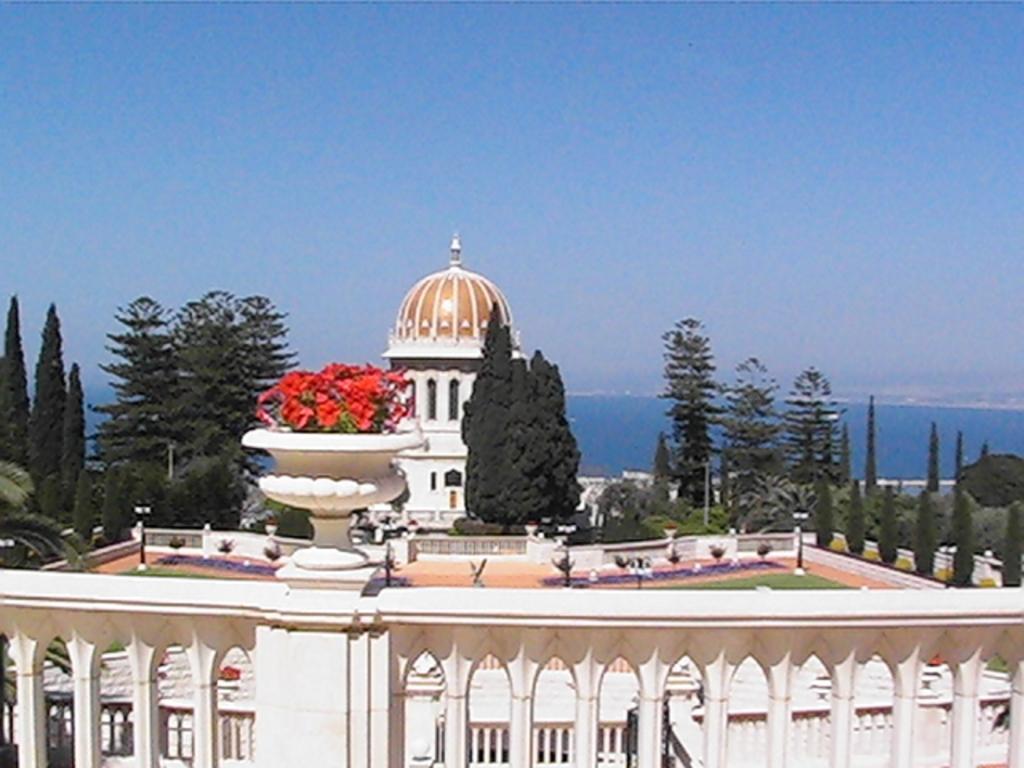Describe this image in one or two sentences. In the center of the image there is a railing and flowers in a flower pot. In the background, we can see the sky, one building, trees and a few other objects. 